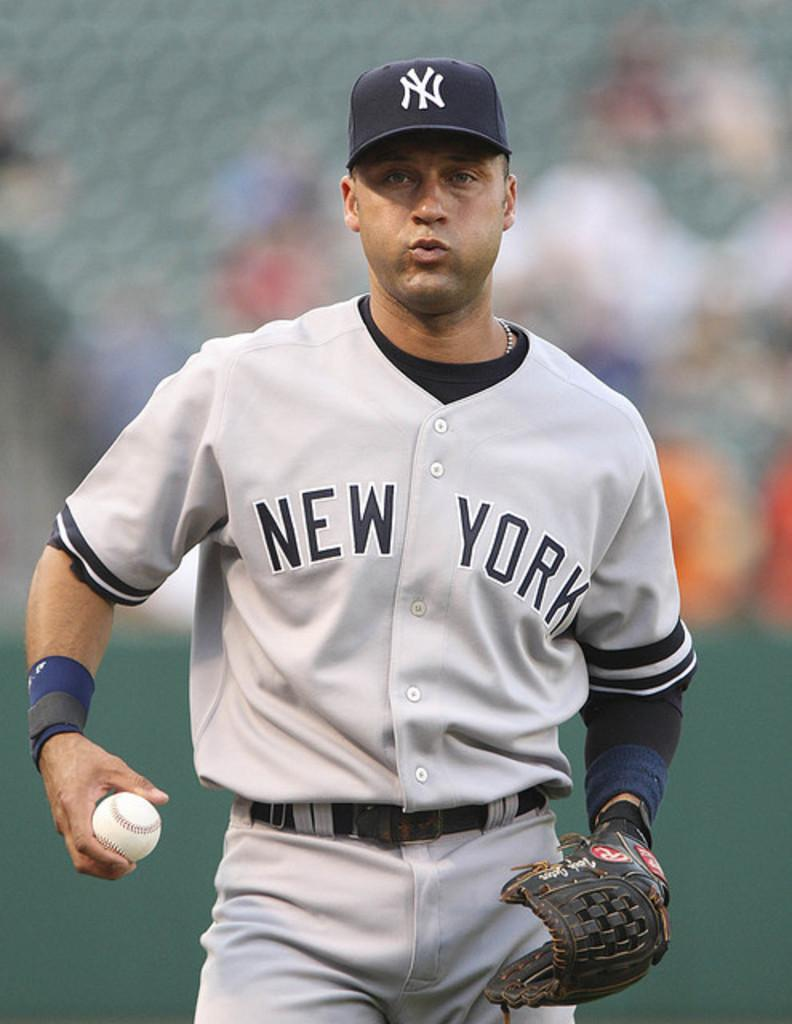<image>
Render a clear and concise summary of the photo. a man in a New York jersey with a ball and mitt in hand 